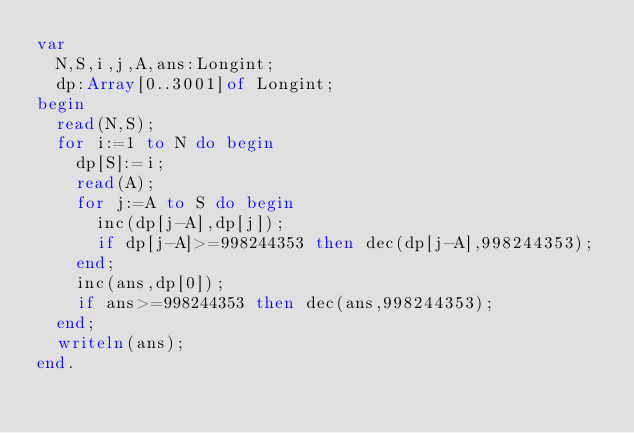<code> <loc_0><loc_0><loc_500><loc_500><_Pascal_>var
	N,S,i,j,A,ans:Longint;
	dp:Array[0..3001]of Longint;
begin
	read(N,S);
	for i:=1 to N do begin
		dp[S]:=i;
		read(A);
		for j:=A to S do begin
			inc(dp[j-A],dp[j]);
			if dp[j-A]>=998244353 then dec(dp[j-A],998244353);
		end;
		inc(ans,dp[0]);
		if ans>=998244353 then dec(ans,998244353);
	end;
	writeln(ans);
end.
</code> 